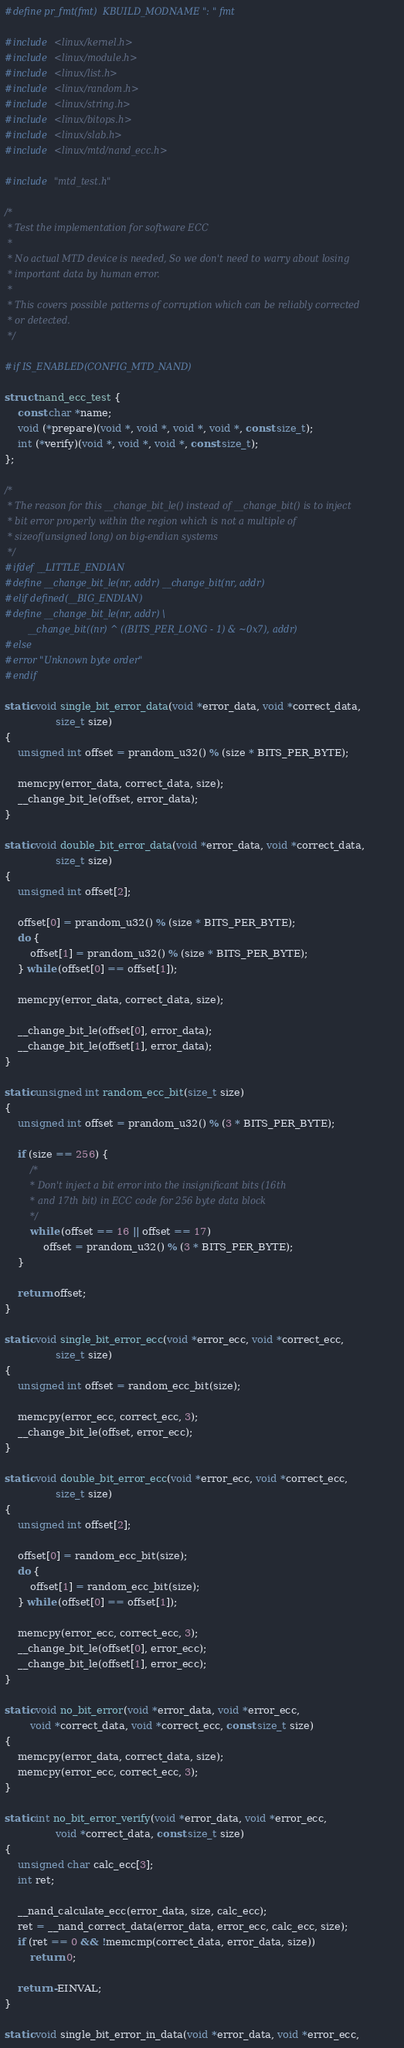Convert code to text. <code><loc_0><loc_0><loc_500><loc_500><_C_>#define pr_fmt(fmt)	KBUILD_MODNAME ": " fmt

#include <linux/kernel.h>
#include <linux/module.h>
#include <linux/list.h>
#include <linux/random.h>
#include <linux/string.h>
#include <linux/bitops.h>
#include <linux/slab.h>
#include <linux/mtd/nand_ecc.h>

#include "mtd_test.h"

/*
 * Test the implementation for software ECC
 *
 * No actual MTD device is needed, So we don't need to warry about losing
 * important data by human error.
 *
 * This covers possible patterns of corruption which can be reliably corrected
 * or detected.
 */

#if IS_ENABLED(CONFIG_MTD_NAND)

struct nand_ecc_test {
	const char *name;
	void (*prepare)(void *, void *, void *, void *, const size_t);
	int (*verify)(void *, void *, void *, const size_t);
};

/*
 * The reason for this __change_bit_le() instead of __change_bit() is to inject
 * bit error properly within the region which is not a multiple of
 * sizeof(unsigned long) on big-endian systems
 */
#ifdef __LITTLE_ENDIAN
#define __change_bit_le(nr, addr) __change_bit(nr, addr)
#elif defined(__BIG_ENDIAN)
#define __change_bit_le(nr, addr) \
		__change_bit((nr) ^ ((BITS_PER_LONG - 1) & ~0x7), addr)
#else
#error "Unknown byte order"
#endif

static void single_bit_error_data(void *error_data, void *correct_data,
				size_t size)
{
	unsigned int offset = prandom_u32() % (size * BITS_PER_BYTE);

	memcpy(error_data, correct_data, size);
	__change_bit_le(offset, error_data);
}

static void double_bit_error_data(void *error_data, void *correct_data,
				size_t size)
{
	unsigned int offset[2];

	offset[0] = prandom_u32() % (size * BITS_PER_BYTE);
	do {
		offset[1] = prandom_u32() % (size * BITS_PER_BYTE);
	} while (offset[0] == offset[1]);

	memcpy(error_data, correct_data, size);

	__change_bit_le(offset[0], error_data);
	__change_bit_le(offset[1], error_data);
}

static unsigned int random_ecc_bit(size_t size)
{
	unsigned int offset = prandom_u32() % (3 * BITS_PER_BYTE);

	if (size == 256) {
		/*
		 * Don't inject a bit error into the insignificant bits (16th
		 * and 17th bit) in ECC code for 256 byte data block
		 */
		while (offset == 16 || offset == 17)
			offset = prandom_u32() % (3 * BITS_PER_BYTE);
	}

	return offset;
}

static void single_bit_error_ecc(void *error_ecc, void *correct_ecc,
				size_t size)
{
	unsigned int offset = random_ecc_bit(size);

	memcpy(error_ecc, correct_ecc, 3);
	__change_bit_le(offset, error_ecc);
}

static void double_bit_error_ecc(void *error_ecc, void *correct_ecc,
				size_t size)
{
	unsigned int offset[2];

	offset[0] = random_ecc_bit(size);
	do {
		offset[1] = random_ecc_bit(size);
	} while (offset[0] == offset[1]);

	memcpy(error_ecc, correct_ecc, 3);
	__change_bit_le(offset[0], error_ecc);
	__change_bit_le(offset[1], error_ecc);
}

static void no_bit_error(void *error_data, void *error_ecc,
		void *correct_data, void *correct_ecc, const size_t size)
{
	memcpy(error_data, correct_data, size);
	memcpy(error_ecc, correct_ecc, 3);
}

static int no_bit_error_verify(void *error_data, void *error_ecc,
				void *correct_data, const size_t size)
{
	unsigned char calc_ecc[3];
	int ret;

	__nand_calculate_ecc(error_data, size, calc_ecc);
	ret = __nand_correct_data(error_data, error_ecc, calc_ecc, size);
	if (ret == 0 && !memcmp(correct_data, error_data, size))
		return 0;

	return -EINVAL;
}

static void single_bit_error_in_data(void *error_data, void *error_ecc,</code> 